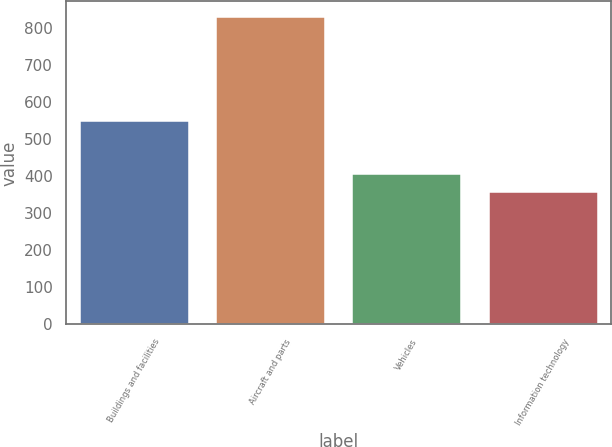Convert chart. <chart><loc_0><loc_0><loc_500><loc_500><bar_chart><fcel>Buildings and facilities<fcel>Aircraft and parts<fcel>Vehicles<fcel>Information technology<nl><fcel>547<fcel>829<fcel>405.1<fcel>358<nl></chart> 